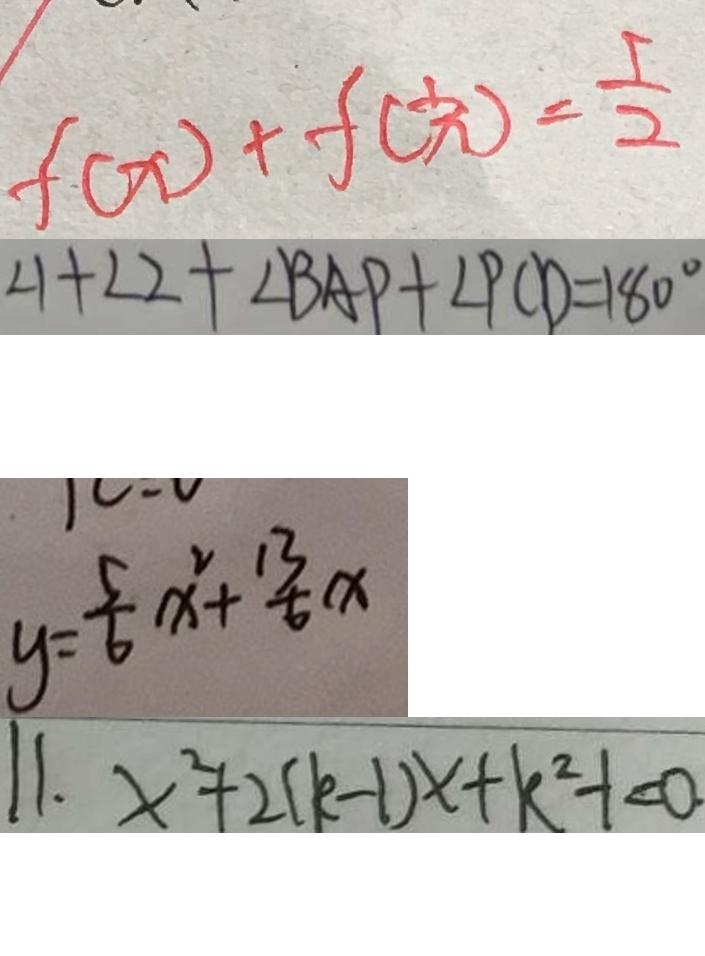<formula> <loc_0><loc_0><loc_500><loc_500>f ( x ) + f ( \frac { 1 } { x } ) = \frac { 5 } { 2 } 
 \angle 1 + \angle 2 + \angle B A P + \angle P C D = 1 8 0 ^ { \circ } 
 y = \frac { 5 } { 6 } x ^ { 2 } + \frac { 1 3 } { 6 } x 
 1 1 . x ^ { 2 } + 2 ( k - 1 ) x + k ^ { 2 } - 1 < 0 .</formula> 